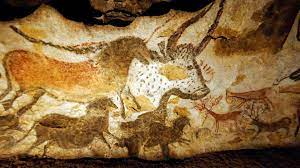What techniques did the artists of the Lascaux Caves use to create these paintings? The artists of the Lascaux Caves utilized several innovative techniques to create their masterpieces. They made pigments from natural minerals like ochre, charcoal, and hematite, grinding them into fine powders. These were then mixed with binders like animal fat to adhere to the cave walls. The artists applied colors with their fingers, brushes made from animal hair, or even blowing pigment onto the wall through hollow reeds, a precursor to modern spray painting techniques. Their skill in using light and shadow, perspective, and the natural contours of the cave walls to enhance the 3D effect of their paintings shows a sophisticated understanding of artistic principles. 